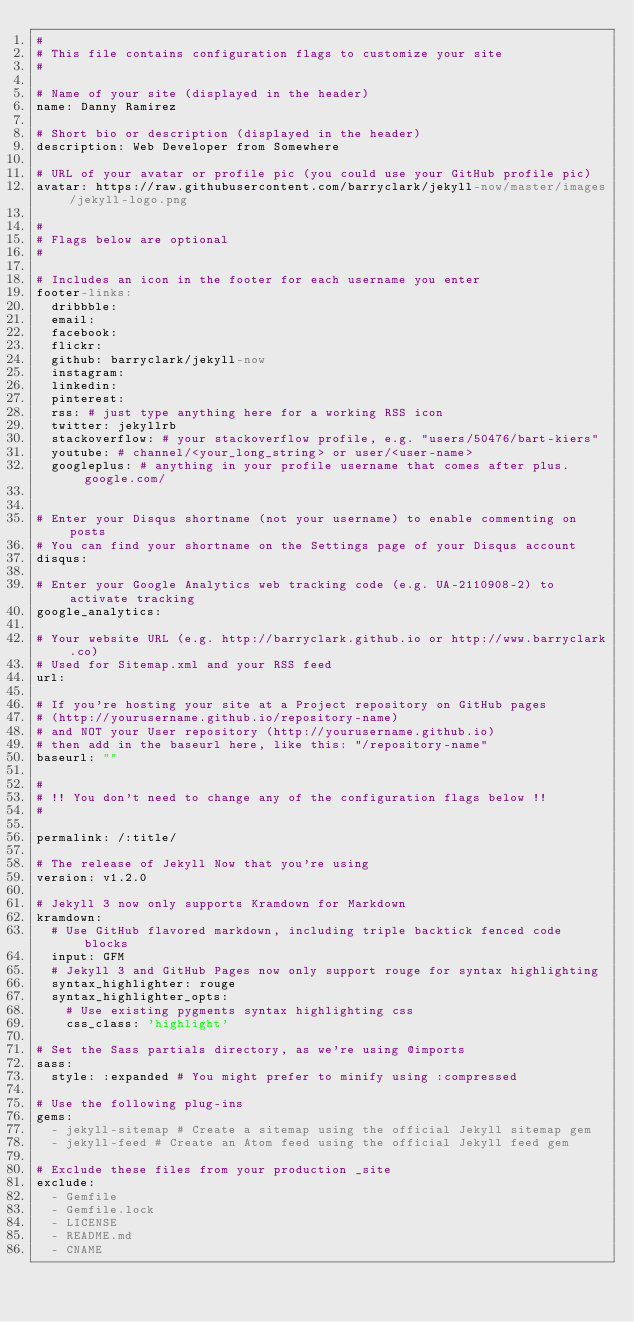<code> <loc_0><loc_0><loc_500><loc_500><_YAML_>#
# This file contains configuration flags to customize your site
#

# Name of your site (displayed in the header)
name: Danny Ramirez

# Short bio or description (displayed in the header)
description: Web Developer from Somewhere

# URL of your avatar or profile pic (you could use your GitHub profile pic)
avatar: https://raw.githubusercontent.com/barryclark/jekyll-now/master/images/jekyll-logo.png

#
# Flags below are optional
#

# Includes an icon in the footer for each username you enter
footer-links:
  dribbble:
  email:
  facebook:
  flickr:
  github: barryclark/jekyll-now
  instagram:
  linkedin:
  pinterest:
  rss: # just type anything here for a working RSS icon
  twitter: jekyllrb
  stackoverflow: # your stackoverflow profile, e.g. "users/50476/bart-kiers"
  youtube: # channel/<your_long_string> or user/<user-name>
  googleplus: # anything in your profile username that comes after plus.google.com/


# Enter your Disqus shortname (not your username) to enable commenting on posts
# You can find your shortname on the Settings page of your Disqus account
disqus:

# Enter your Google Analytics web tracking code (e.g. UA-2110908-2) to activate tracking
google_analytics:

# Your website URL (e.g. http://barryclark.github.io or http://www.barryclark.co)
# Used for Sitemap.xml and your RSS feed
url:

# If you're hosting your site at a Project repository on GitHub pages
# (http://yourusername.github.io/repository-name)
# and NOT your User repository (http://yourusername.github.io)
# then add in the baseurl here, like this: "/repository-name"
baseurl: ""

#
# !! You don't need to change any of the configuration flags below !!
#

permalink: /:title/

# The release of Jekyll Now that you're using
version: v1.2.0

# Jekyll 3 now only supports Kramdown for Markdown
kramdown:
  # Use GitHub flavored markdown, including triple backtick fenced code blocks
  input: GFM
  # Jekyll 3 and GitHub Pages now only support rouge for syntax highlighting
  syntax_highlighter: rouge
  syntax_highlighter_opts:
    # Use existing pygments syntax highlighting css
    css_class: 'highlight'

# Set the Sass partials directory, as we're using @imports
sass:
  style: :expanded # You might prefer to minify using :compressed

# Use the following plug-ins
gems:
  - jekyll-sitemap # Create a sitemap using the official Jekyll sitemap gem
  - jekyll-feed # Create an Atom feed using the official Jekyll feed gem

# Exclude these files from your production _site
exclude:
  - Gemfile
  - Gemfile.lock
  - LICENSE
  - README.md
  - CNAME
</code> 